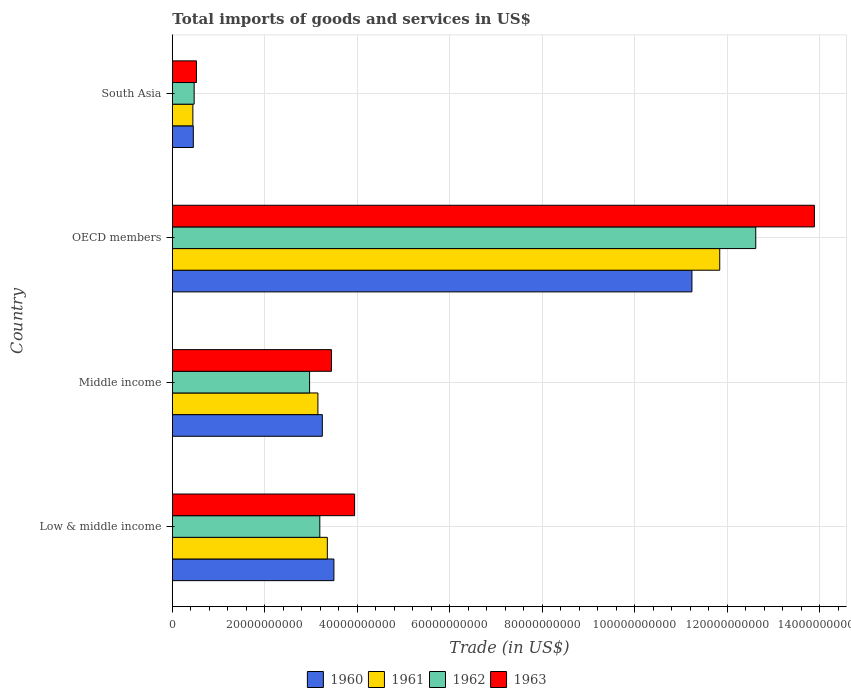How many different coloured bars are there?
Offer a very short reply. 4. How many groups of bars are there?
Offer a very short reply. 4. Are the number of bars on each tick of the Y-axis equal?
Give a very brief answer. Yes. What is the total imports of goods and services in 1962 in Middle income?
Provide a succinct answer. 2.97e+1. Across all countries, what is the maximum total imports of goods and services in 1961?
Your response must be concise. 1.18e+11. Across all countries, what is the minimum total imports of goods and services in 1961?
Your answer should be compact. 4.43e+09. In which country was the total imports of goods and services in 1963 minimum?
Offer a very short reply. South Asia. What is the total total imports of goods and services in 1962 in the graph?
Ensure brevity in your answer.  1.92e+11. What is the difference between the total imports of goods and services in 1960 in OECD members and that in South Asia?
Give a very brief answer. 1.08e+11. What is the difference between the total imports of goods and services in 1963 in South Asia and the total imports of goods and services in 1962 in Low & middle income?
Your response must be concise. -2.67e+1. What is the average total imports of goods and services in 1961 per country?
Your response must be concise. 4.69e+1. What is the difference between the total imports of goods and services in 1960 and total imports of goods and services in 1962 in Middle income?
Ensure brevity in your answer.  2.76e+09. What is the ratio of the total imports of goods and services in 1960 in Middle income to that in OECD members?
Offer a very short reply. 0.29. Is the total imports of goods and services in 1960 in OECD members less than that in South Asia?
Offer a terse response. No. What is the difference between the highest and the second highest total imports of goods and services in 1962?
Offer a very short reply. 9.43e+1. What is the difference between the highest and the lowest total imports of goods and services in 1963?
Provide a succinct answer. 1.34e+11. Is the sum of the total imports of goods and services in 1963 in Middle income and South Asia greater than the maximum total imports of goods and services in 1960 across all countries?
Give a very brief answer. No. What does the 2nd bar from the top in OECD members represents?
Make the answer very short. 1962. Are all the bars in the graph horizontal?
Provide a short and direct response. Yes. How many countries are there in the graph?
Provide a short and direct response. 4. Does the graph contain any zero values?
Provide a short and direct response. No. Where does the legend appear in the graph?
Give a very brief answer. Bottom center. What is the title of the graph?
Give a very brief answer. Total imports of goods and services in US$. Does "1998" appear as one of the legend labels in the graph?
Offer a terse response. No. What is the label or title of the X-axis?
Give a very brief answer. Trade (in US$). What is the label or title of the Y-axis?
Provide a short and direct response. Country. What is the Trade (in US$) of 1960 in Low & middle income?
Give a very brief answer. 3.49e+1. What is the Trade (in US$) in 1961 in Low & middle income?
Your response must be concise. 3.35e+1. What is the Trade (in US$) of 1962 in Low & middle income?
Provide a succinct answer. 3.19e+1. What is the Trade (in US$) in 1963 in Low & middle income?
Your answer should be compact. 3.94e+1. What is the Trade (in US$) of 1960 in Middle income?
Ensure brevity in your answer.  3.24e+1. What is the Trade (in US$) in 1961 in Middle income?
Ensure brevity in your answer.  3.15e+1. What is the Trade (in US$) of 1962 in Middle income?
Provide a succinct answer. 2.97e+1. What is the Trade (in US$) of 1963 in Middle income?
Ensure brevity in your answer.  3.44e+1. What is the Trade (in US$) in 1960 in OECD members?
Provide a short and direct response. 1.12e+11. What is the Trade (in US$) of 1961 in OECD members?
Give a very brief answer. 1.18e+11. What is the Trade (in US$) of 1962 in OECD members?
Offer a terse response. 1.26e+11. What is the Trade (in US$) of 1963 in OECD members?
Ensure brevity in your answer.  1.39e+11. What is the Trade (in US$) of 1960 in South Asia?
Your answer should be very brief. 4.53e+09. What is the Trade (in US$) of 1961 in South Asia?
Your answer should be very brief. 4.43e+09. What is the Trade (in US$) in 1962 in South Asia?
Give a very brief answer. 4.71e+09. What is the Trade (in US$) in 1963 in South Asia?
Your answer should be very brief. 5.21e+09. Across all countries, what is the maximum Trade (in US$) in 1960?
Offer a very short reply. 1.12e+11. Across all countries, what is the maximum Trade (in US$) of 1961?
Offer a terse response. 1.18e+11. Across all countries, what is the maximum Trade (in US$) in 1962?
Make the answer very short. 1.26e+11. Across all countries, what is the maximum Trade (in US$) in 1963?
Give a very brief answer. 1.39e+11. Across all countries, what is the minimum Trade (in US$) of 1960?
Provide a short and direct response. 4.53e+09. Across all countries, what is the minimum Trade (in US$) in 1961?
Give a very brief answer. 4.43e+09. Across all countries, what is the minimum Trade (in US$) of 1962?
Provide a short and direct response. 4.71e+09. Across all countries, what is the minimum Trade (in US$) in 1963?
Provide a succinct answer. 5.21e+09. What is the total Trade (in US$) of 1960 in the graph?
Offer a terse response. 1.84e+11. What is the total Trade (in US$) of 1961 in the graph?
Your response must be concise. 1.88e+11. What is the total Trade (in US$) in 1962 in the graph?
Your answer should be very brief. 1.92e+11. What is the total Trade (in US$) of 1963 in the graph?
Offer a very short reply. 2.18e+11. What is the difference between the Trade (in US$) in 1960 in Low & middle income and that in Middle income?
Give a very brief answer. 2.50e+09. What is the difference between the Trade (in US$) in 1961 in Low & middle income and that in Middle income?
Your response must be concise. 2.04e+09. What is the difference between the Trade (in US$) in 1962 in Low & middle income and that in Middle income?
Make the answer very short. 2.21e+09. What is the difference between the Trade (in US$) in 1963 in Low & middle income and that in Middle income?
Ensure brevity in your answer.  5.01e+09. What is the difference between the Trade (in US$) of 1960 in Low & middle income and that in OECD members?
Provide a succinct answer. -7.74e+1. What is the difference between the Trade (in US$) of 1961 in Low & middle income and that in OECD members?
Your answer should be very brief. -8.48e+1. What is the difference between the Trade (in US$) in 1962 in Low & middle income and that in OECD members?
Ensure brevity in your answer.  -9.43e+1. What is the difference between the Trade (in US$) of 1963 in Low & middle income and that in OECD members?
Your response must be concise. -9.94e+1. What is the difference between the Trade (in US$) of 1960 in Low & middle income and that in South Asia?
Keep it short and to the point. 3.04e+1. What is the difference between the Trade (in US$) of 1961 in Low & middle income and that in South Asia?
Provide a succinct answer. 2.91e+1. What is the difference between the Trade (in US$) of 1962 in Low & middle income and that in South Asia?
Provide a short and direct response. 2.72e+1. What is the difference between the Trade (in US$) in 1963 in Low & middle income and that in South Asia?
Give a very brief answer. 3.42e+1. What is the difference between the Trade (in US$) of 1960 in Middle income and that in OECD members?
Provide a short and direct response. -7.99e+1. What is the difference between the Trade (in US$) in 1961 in Middle income and that in OECD members?
Provide a succinct answer. -8.69e+1. What is the difference between the Trade (in US$) of 1962 in Middle income and that in OECD members?
Make the answer very short. -9.65e+1. What is the difference between the Trade (in US$) of 1963 in Middle income and that in OECD members?
Offer a terse response. -1.04e+11. What is the difference between the Trade (in US$) of 1960 in Middle income and that in South Asia?
Your answer should be compact. 2.79e+1. What is the difference between the Trade (in US$) in 1961 in Middle income and that in South Asia?
Offer a very short reply. 2.70e+1. What is the difference between the Trade (in US$) of 1962 in Middle income and that in South Asia?
Give a very brief answer. 2.50e+1. What is the difference between the Trade (in US$) of 1963 in Middle income and that in South Asia?
Offer a very short reply. 2.92e+1. What is the difference between the Trade (in US$) of 1960 in OECD members and that in South Asia?
Provide a succinct answer. 1.08e+11. What is the difference between the Trade (in US$) in 1961 in OECD members and that in South Asia?
Offer a terse response. 1.14e+11. What is the difference between the Trade (in US$) in 1962 in OECD members and that in South Asia?
Offer a very short reply. 1.21e+11. What is the difference between the Trade (in US$) of 1963 in OECD members and that in South Asia?
Give a very brief answer. 1.34e+11. What is the difference between the Trade (in US$) in 1960 in Low & middle income and the Trade (in US$) in 1961 in Middle income?
Your response must be concise. 3.46e+09. What is the difference between the Trade (in US$) of 1960 in Low & middle income and the Trade (in US$) of 1962 in Middle income?
Ensure brevity in your answer.  5.26e+09. What is the difference between the Trade (in US$) in 1960 in Low & middle income and the Trade (in US$) in 1963 in Middle income?
Your answer should be very brief. 5.30e+08. What is the difference between the Trade (in US$) in 1961 in Low & middle income and the Trade (in US$) in 1962 in Middle income?
Ensure brevity in your answer.  3.84e+09. What is the difference between the Trade (in US$) in 1961 in Low & middle income and the Trade (in US$) in 1963 in Middle income?
Keep it short and to the point. -8.90e+08. What is the difference between the Trade (in US$) of 1962 in Low & middle income and the Trade (in US$) of 1963 in Middle income?
Your answer should be very brief. -2.51e+09. What is the difference between the Trade (in US$) of 1960 in Low & middle income and the Trade (in US$) of 1961 in OECD members?
Keep it short and to the point. -8.34e+1. What is the difference between the Trade (in US$) of 1960 in Low & middle income and the Trade (in US$) of 1962 in OECD members?
Your answer should be compact. -9.12e+1. What is the difference between the Trade (in US$) in 1960 in Low & middle income and the Trade (in US$) in 1963 in OECD members?
Your answer should be very brief. -1.04e+11. What is the difference between the Trade (in US$) of 1961 in Low & middle income and the Trade (in US$) of 1962 in OECD members?
Give a very brief answer. -9.26e+1. What is the difference between the Trade (in US$) in 1961 in Low & middle income and the Trade (in US$) in 1963 in OECD members?
Give a very brief answer. -1.05e+11. What is the difference between the Trade (in US$) of 1962 in Low & middle income and the Trade (in US$) of 1963 in OECD members?
Give a very brief answer. -1.07e+11. What is the difference between the Trade (in US$) of 1960 in Low & middle income and the Trade (in US$) of 1961 in South Asia?
Offer a very short reply. 3.05e+1. What is the difference between the Trade (in US$) of 1960 in Low & middle income and the Trade (in US$) of 1962 in South Asia?
Keep it short and to the point. 3.02e+1. What is the difference between the Trade (in US$) in 1960 in Low & middle income and the Trade (in US$) in 1963 in South Asia?
Provide a short and direct response. 2.97e+1. What is the difference between the Trade (in US$) in 1961 in Low & middle income and the Trade (in US$) in 1962 in South Asia?
Keep it short and to the point. 2.88e+1. What is the difference between the Trade (in US$) in 1961 in Low & middle income and the Trade (in US$) in 1963 in South Asia?
Give a very brief answer. 2.83e+1. What is the difference between the Trade (in US$) in 1962 in Low & middle income and the Trade (in US$) in 1963 in South Asia?
Keep it short and to the point. 2.67e+1. What is the difference between the Trade (in US$) in 1960 in Middle income and the Trade (in US$) in 1961 in OECD members?
Your answer should be very brief. -8.59e+1. What is the difference between the Trade (in US$) of 1960 in Middle income and the Trade (in US$) of 1962 in OECD members?
Your response must be concise. -9.37e+1. What is the difference between the Trade (in US$) in 1960 in Middle income and the Trade (in US$) in 1963 in OECD members?
Provide a succinct answer. -1.06e+11. What is the difference between the Trade (in US$) of 1961 in Middle income and the Trade (in US$) of 1962 in OECD members?
Provide a short and direct response. -9.47e+1. What is the difference between the Trade (in US$) of 1961 in Middle income and the Trade (in US$) of 1963 in OECD members?
Offer a very short reply. -1.07e+11. What is the difference between the Trade (in US$) in 1962 in Middle income and the Trade (in US$) in 1963 in OECD members?
Provide a short and direct response. -1.09e+11. What is the difference between the Trade (in US$) of 1960 in Middle income and the Trade (in US$) of 1961 in South Asia?
Your answer should be very brief. 2.80e+1. What is the difference between the Trade (in US$) of 1960 in Middle income and the Trade (in US$) of 1962 in South Asia?
Your answer should be compact. 2.77e+1. What is the difference between the Trade (in US$) of 1960 in Middle income and the Trade (in US$) of 1963 in South Asia?
Give a very brief answer. 2.72e+1. What is the difference between the Trade (in US$) in 1961 in Middle income and the Trade (in US$) in 1962 in South Asia?
Your answer should be very brief. 2.68e+1. What is the difference between the Trade (in US$) in 1961 in Middle income and the Trade (in US$) in 1963 in South Asia?
Your response must be concise. 2.63e+1. What is the difference between the Trade (in US$) in 1962 in Middle income and the Trade (in US$) in 1963 in South Asia?
Your answer should be compact. 2.45e+1. What is the difference between the Trade (in US$) in 1960 in OECD members and the Trade (in US$) in 1961 in South Asia?
Provide a succinct answer. 1.08e+11. What is the difference between the Trade (in US$) in 1960 in OECD members and the Trade (in US$) in 1962 in South Asia?
Provide a succinct answer. 1.08e+11. What is the difference between the Trade (in US$) in 1960 in OECD members and the Trade (in US$) in 1963 in South Asia?
Offer a very short reply. 1.07e+11. What is the difference between the Trade (in US$) of 1961 in OECD members and the Trade (in US$) of 1962 in South Asia?
Provide a succinct answer. 1.14e+11. What is the difference between the Trade (in US$) of 1961 in OECD members and the Trade (in US$) of 1963 in South Asia?
Keep it short and to the point. 1.13e+11. What is the difference between the Trade (in US$) in 1962 in OECD members and the Trade (in US$) in 1963 in South Asia?
Provide a short and direct response. 1.21e+11. What is the average Trade (in US$) in 1960 per country?
Provide a succinct answer. 4.61e+1. What is the average Trade (in US$) of 1961 per country?
Your response must be concise. 4.69e+1. What is the average Trade (in US$) in 1962 per country?
Offer a terse response. 4.81e+1. What is the average Trade (in US$) in 1963 per country?
Provide a short and direct response. 5.45e+1. What is the difference between the Trade (in US$) in 1960 and Trade (in US$) in 1961 in Low & middle income?
Make the answer very short. 1.42e+09. What is the difference between the Trade (in US$) of 1960 and Trade (in US$) of 1962 in Low & middle income?
Make the answer very short. 3.05e+09. What is the difference between the Trade (in US$) in 1960 and Trade (in US$) in 1963 in Low & middle income?
Your answer should be compact. -4.48e+09. What is the difference between the Trade (in US$) in 1961 and Trade (in US$) in 1962 in Low & middle income?
Offer a terse response. 1.62e+09. What is the difference between the Trade (in US$) of 1961 and Trade (in US$) of 1963 in Low & middle income?
Give a very brief answer. -5.90e+09. What is the difference between the Trade (in US$) in 1962 and Trade (in US$) in 1963 in Low & middle income?
Your response must be concise. -7.52e+09. What is the difference between the Trade (in US$) of 1960 and Trade (in US$) of 1961 in Middle income?
Keep it short and to the point. 9.57e+08. What is the difference between the Trade (in US$) in 1960 and Trade (in US$) in 1962 in Middle income?
Offer a terse response. 2.76e+09. What is the difference between the Trade (in US$) in 1960 and Trade (in US$) in 1963 in Middle income?
Ensure brevity in your answer.  -1.97e+09. What is the difference between the Trade (in US$) in 1961 and Trade (in US$) in 1962 in Middle income?
Your answer should be compact. 1.80e+09. What is the difference between the Trade (in US$) of 1961 and Trade (in US$) of 1963 in Middle income?
Your answer should be very brief. -2.93e+09. What is the difference between the Trade (in US$) in 1962 and Trade (in US$) in 1963 in Middle income?
Give a very brief answer. -4.73e+09. What is the difference between the Trade (in US$) in 1960 and Trade (in US$) in 1961 in OECD members?
Your answer should be very brief. -6.01e+09. What is the difference between the Trade (in US$) of 1960 and Trade (in US$) of 1962 in OECD members?
Keep it short and to the point. -1.38e+1. What is the difference between the Trade (in US$) of 1960 and Trade (in US$) of 1963 in OECD members?
Offer a terse response. -2.65e+1. What is the difference between the Trade (in US$) of 1961 and Trade (in US$) of 1962 in OECD members?
Provide a succinct answer. -7.79e+09. What is the difference between the Trade (in US$) in 1961 and Trade (in US$) in 1963 in OECD members?
Your response must be concise. -2.05e+1. What is the difference between the Trade (in US$) in 1962 and Trade (in US$) in 1963 in OECD members?
Provide a succinct answer. -1.27e+1. What is the difference between the Trade (in US$) of 1960 and Trade (in US$) of 1961 in South Asia?
Ensure brevity in your answer.  9.31e+07. What is the difference between the Trade (in US$) of 1960 and Trade (in US$) of 1962 in South Asia?
Give a very brief answer. -1.84e+08. What is the difference between the Trade (in US$) in 1960 and Trade (in US$) in 1963 in South Asia?
Ensure brevity in your answer.  -6.84e+08. What is the difference between the Trade (in US$) in 1961 and Trade (in US$) in 1962 in South Asia?
Keep it short and to the point. -2.77e+08. What is the difference between the Trade (in US$) of 1961 and Trade (in US$) of 1963 in South Asia?
Offer a terse response. -7.77e+08. What is the difference between the Trade (in US$) of 1962 and Trade (in US$) of 1963 in South Asia?
Ensure brevity in your answer.  -5.00e+08. What is the ratio of the Trade (in US$) in 1960 in Low & middle income to that in Middle income?
Your response must be concise. 1.08. What is the ratio of the Trade (in US$) of 1961 in Low & middle income to that in Middle income?
Keep it short and to the point. 1.06. What is the ratio of the Trade (in US$) in 1962 in Low & middle income to that in Middle income?
Your answer should be compact. 1.07. What is the ratio of the Trade (in US$) in 1963 in Low & middle income to that in Middle income?
Your response must be concise. 1.15. What is the ratio of the Trade (in US$) in 1960 in Low & middle income to that in OECD members?
Offer a terse response. 0.31. What is the ratio of the Trade (in US$) of 1961 in Low & middle income to that in OECD members?
Offer a very short reply. 0.28. What is the ratio of the Trade (in US$) in 1962 in Low & middle income to that in OECD members?
Provide a short and direct response. 0.25. What is the ratio of the Trade (in US$) of 1963 in Low & middle income to that in OECD members?
Provide a succinct answer. 0.28. What is the ratio of the Trade (in US$) in 1960 in Low & middle income to that in South Asia?
Your answer should be very brief. 7.71. What is the ratio of the Trade (in US$) of 1961 in Low & middle income to that in South Asia?
Provide a short and direct response. 7.55. What is the ratio of the Trade (in US$) of 1962 in Low & middle income to that in South Asia?
Your answer should be very brief. 6.77. What is the ratio of the Trade (in US$) in 1963 in Low & middle income to that in South Asia?
Offer a terse response. 7.56. What is the ratio of the Trade (in US$) of 1960 in Middle income to that in OECD members?
Provide a short and direct response. 0.29. What is the ratio of the Trade (in US$) of 1961 in Middle income to that in OECD members?
Your answer should be compact. 0.27. What is the ratio of the Trade (in US$) in 1962 in Middle income to that in OECD members?
Offer a terse response. 0.24. What is the ratio of the Trade (in US$) of 1963 in Middle income to that in OECD members?
Give a very brief answer. 0.25. What is the ratio of the Trade (in US$) of 1960 in Middle income to that in South Asia?
Your response must be concise. 7.16. What is the ratio of the Trade (in US$) of 1961 in Middle income to that in South Asia?
Your answer should be very brief. 7.1. What is the ratio of the Trade (in US$) of 1962 in Middle income to that in South Asia?
Make the answer very short. 6.3. What is the ratio of the Trade (in US$) of 1963 in Middle income to that in South Asia?
Provide a succinct answer. 6.6. What is the ratio of the Trade (in US$) in 1960 in OECD members to that in South Asia?
Provide a short and direct response. 24.81. What is the ratio of the Trade (in US$) of 1961 in OECD members to that in South Asia?
Offer a terse response. 26.69. What is the ratio of the Trade (in US$) in 1962 in OECD members to that in South Asia?
Offer a terse response. 26.77. What is the ratio of the Trade (in US$) in 1963 in OECD members to that in South Asia?
Provide a succinct answer. 26.63. What is the difference between the highest and the second highest Trade (in US$) in 1960?
Provide a succinct answer. 7.74e+1. What is the difference between the highest and the second highest Trade (in US$) of 1961?
Your response must be concise. 8.48e+1. What is the difference between the highest and the second highest Trade (in US$) in 1962?
Your response must be concise. 9.43e+1. What is the difference between the highest and the second highest Trade (in US$) of 1963?
Make the answer very short. 9.94e+1. What is the difference between the highest and the lowest Trade (in US$) of 1960?
Keep it short and to the point. 1.08e+11. What is the difference between the highest and the lowest Trade (in US$) in 1961?
Your answer should be very brief. 1.14e+11. What is the difference between the highest and the lowest Trade (in US$) of 1962?
Make the answer very short. 1.21e+11. What is the difference between the highest and the lowest Trade (in US$) of 1963?
Make the answer very short. 1.34e+11. 